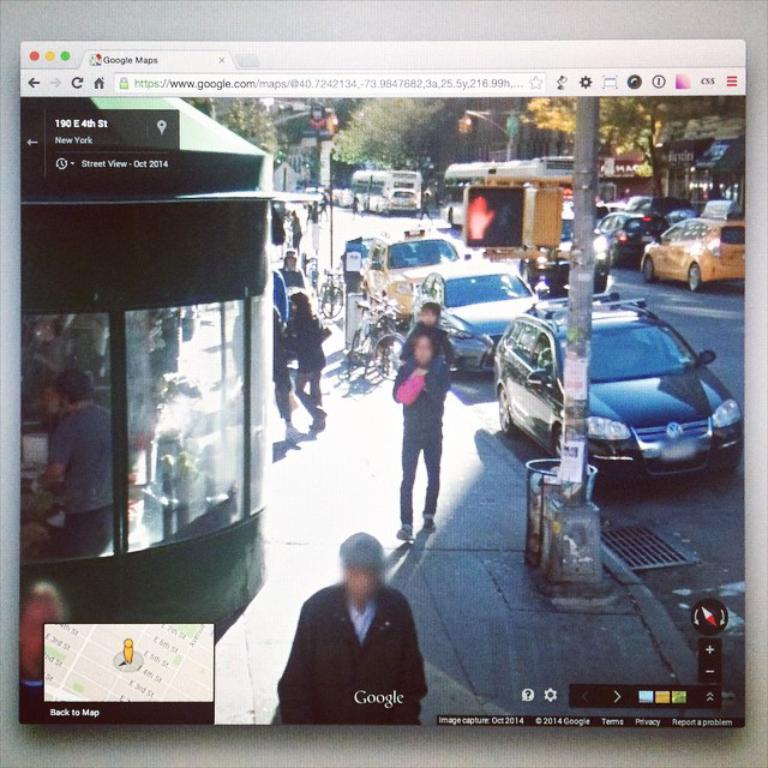What can be seen on the road in the image? There are vehicles on the road in the image. Who or what else can be seen in the image? There are people visible in the image. What is the tall, vertical object in the image? There is a pole in the image. What type of natural vegetation is present in the image? There are trees in the image. What type of establishment can be seen in the image? There is a store in the image. Can you tell me how many scarves are being worn by the people in the image? There is no information about scarves in the image, so it is impossible to determine how many people are wearing them. Is there an expert visible in the image? The image does not provide any information about the expertise of the people present, so it is impossible to determine if an expert is visible. 